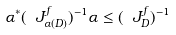<formula> <loc_0><loc_0><loc_500><loc_500>\alpha ^ { * } ( \ J _ { \alpha ( D ) } ^ { f } ) ^ { - 1 } \alpha \leq ( \ J _ { D } ^ { f } ) ^ { - 1 }</formula> 